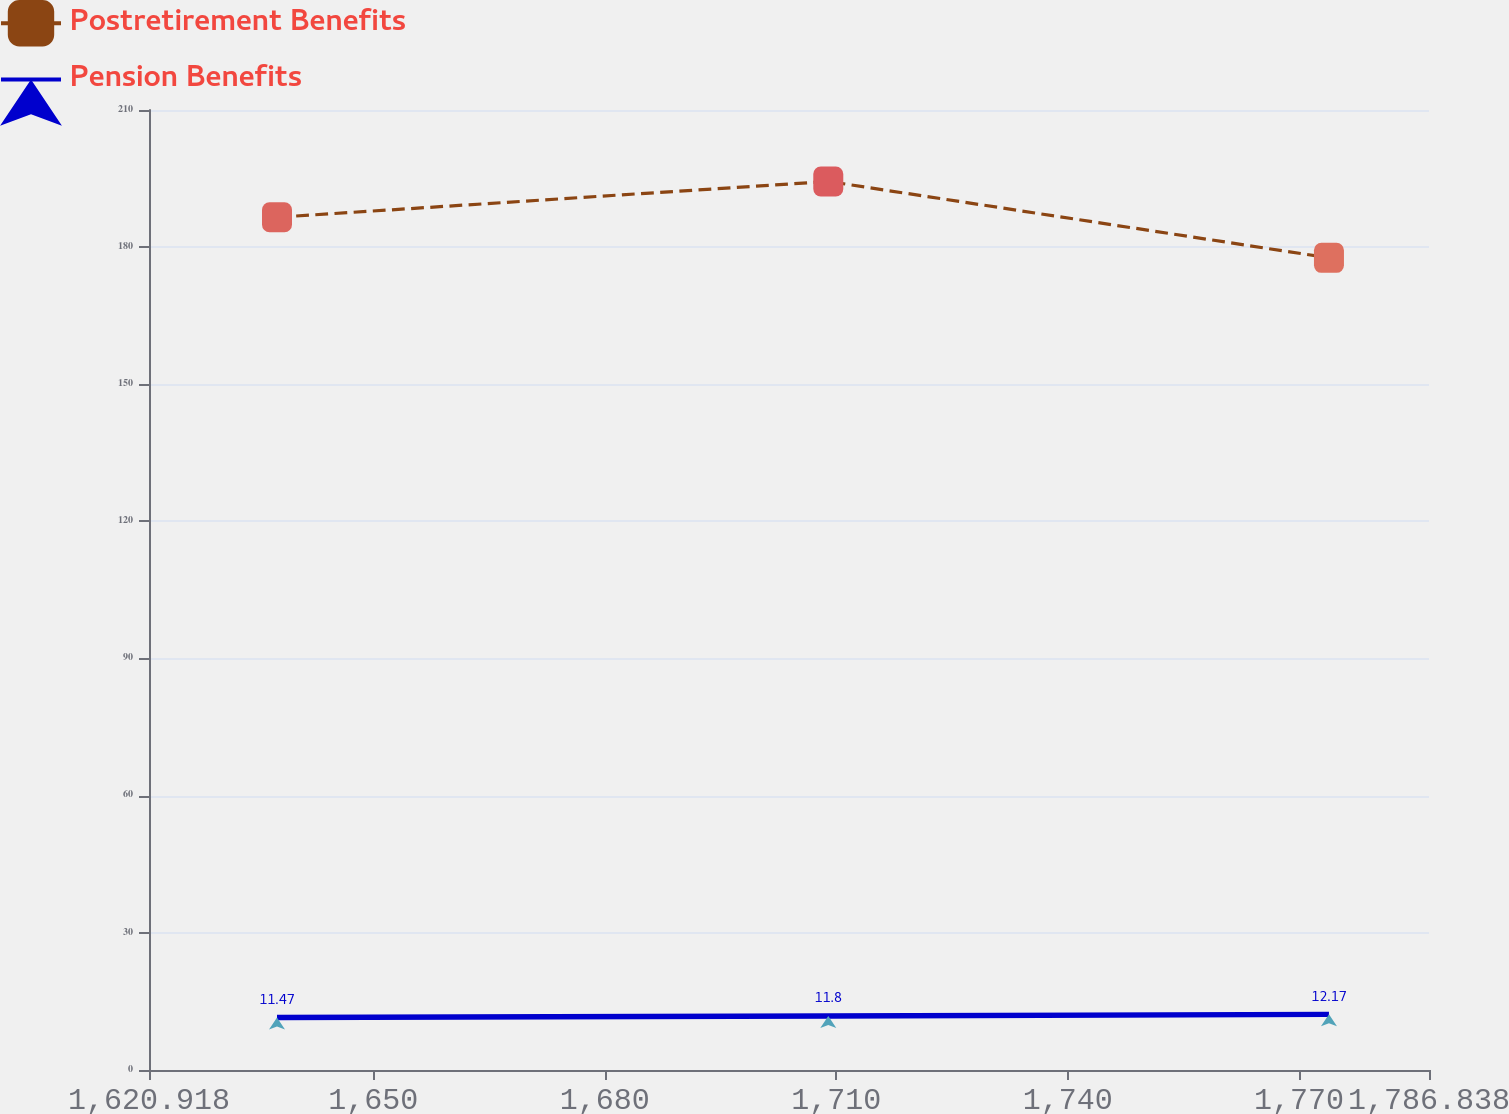Convert chart. <chart><loc_0><loc_0><loc_500><loc_500><line_chart><ecel><fcel>Postretirement Benefits<fcel>Pension Benefits<nl><fcel>1637.51<fcel>186.54<fcel>11.47<nl><fcel>1708.97<fcel>194.37<fcel>11.8<nl><fcel>1773.87<fcel>177.66<fcel>12.17<nl><fcel>1788.65<fcel>204.77<fcel>13.81<nl><fcel>1803.43<fcel>174.65<fcel>14.77<nl></chart> 